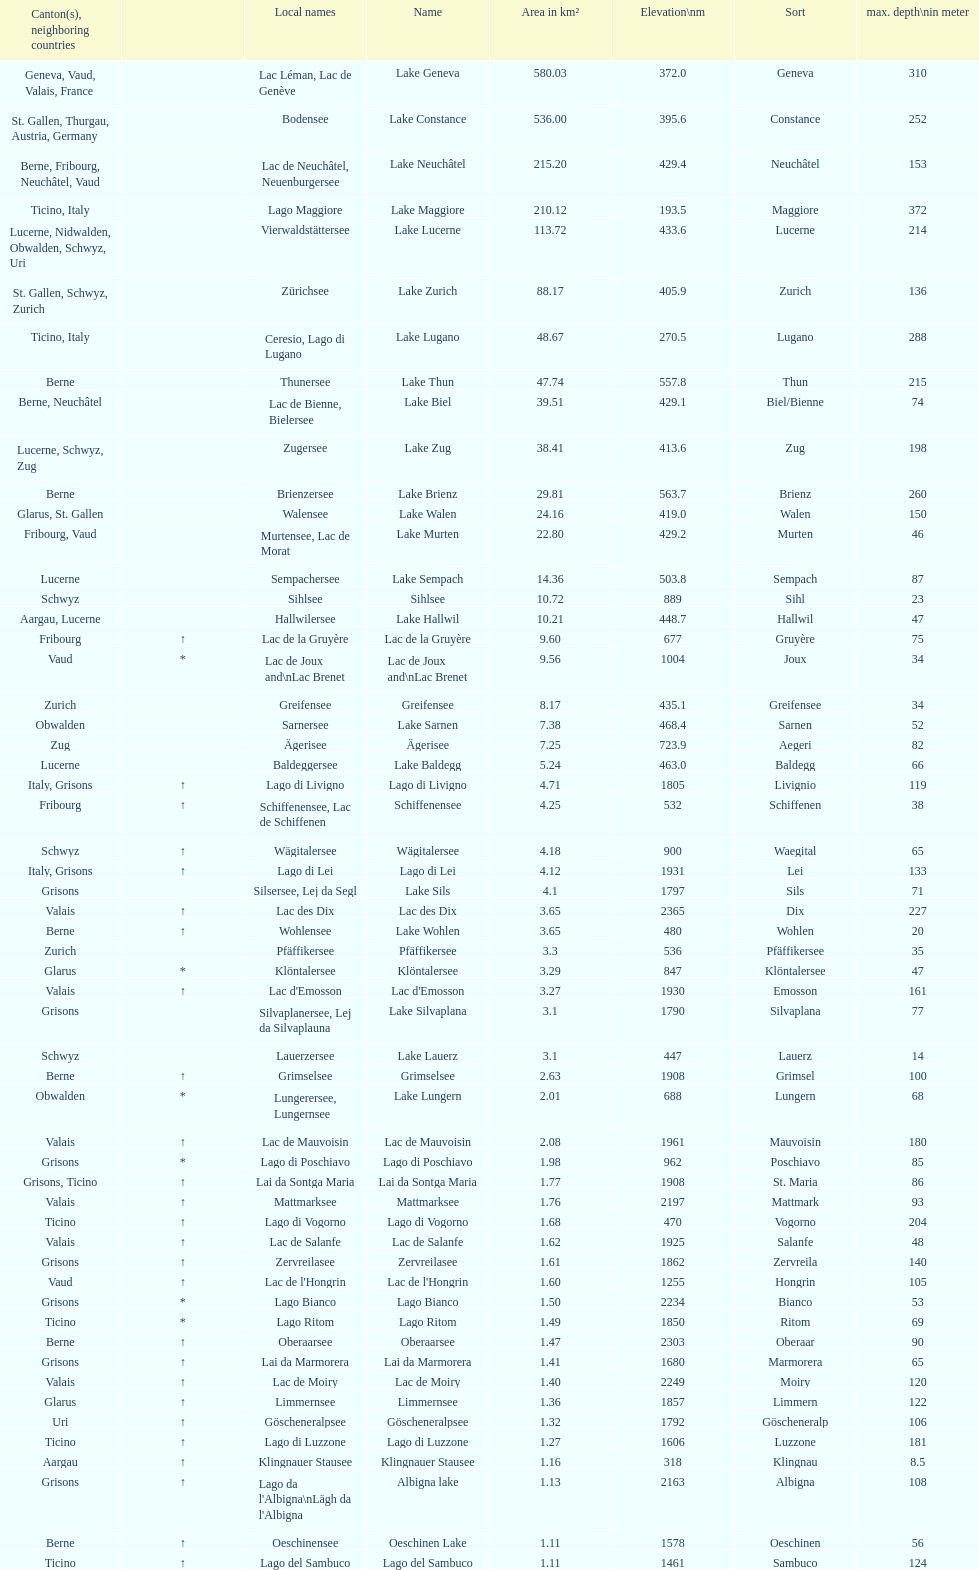Which lake has the greatest elevation? Lac des Dix. 